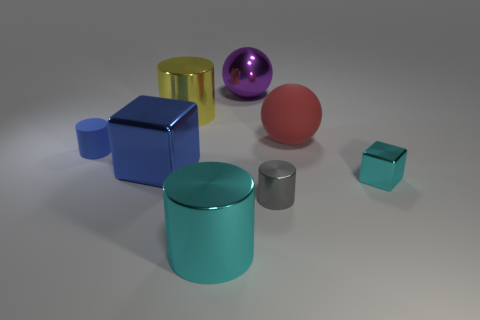Subtract all cyan cylinders. How many cylinders are left? 3 Subtract all cyan cylinders. How many cylinders are left? 3 Subtract 1 cylinders. How many cylinders are left? 3 Add 1 balls. How many objects exist? 9 Subtract all cubes. How many objects are left? 6 Add 2 big red spheres. How many big red spheres exist? 3 Subtract 0 brown cylinders. How many objects are left? 8 Subtract all brown blocks. Subtract all gray spheres. How many blocks are left? 2 Subtract all small brown blocks. Subtract all large shiny cylinders. How many objects are left? 6 Add 6 gray cylinders. How many gray cylinders are left? 7 